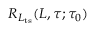Convert formula to latex. <formula><loc_0><loc_0><loc_500><loc_500>R _ { L _ { t s } } ( L , \tau ; \tau _ { 0 } )</formula> 